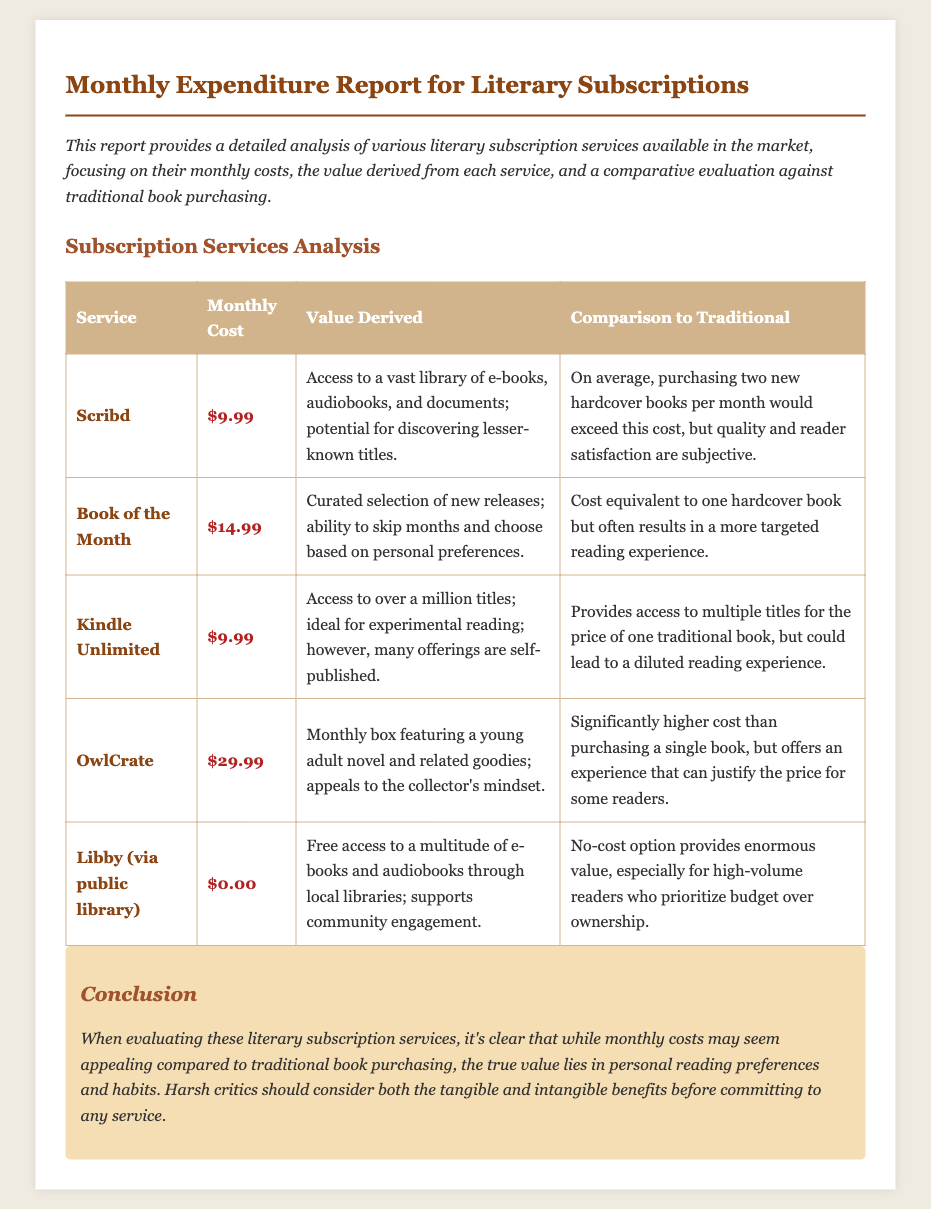What is the monthly cost of Scribd? The monthly cost of Scribd is stated in the document.
Answer: $9.99 What value does Kindle Unlimited provide? The document describes the value derived from Kindle Unlimited.
Answer: Access to over a million titles How much does OwlCrate cost per month? The cost of OwlCrate is clearly listed in the analysis section.
Answer: $29.99 What is unique about the value derived from Libby? The document mentions the distinctive benefits of using Libby.
Answer: Free access to a multitude of e-books and audiobooks Which subscription service offers a curated selection of new releases? The document explicitly identifies the service that provides a curated selection.
Answer: Book of the Month How does the cost of Kindle Unlimited compare to purchasing traditional books? The comparison discusses the cost relationship between Kindle Unlimited and traditional book purchasing.
Answer: Provides access to multiple titles for the price of one traditional book What is the conclusion drawn about evaluating literary subscription services? The conclusion section summarizes the insights about subscription services.
Answer: The true value lies in personal reading preferences and habits What is the highest monthly cost among the services listed? The question asks for the maximum cost of the listed services, which can be found in the table.
Answer: $29.99 What aspect does the document focus on in its analysis? The introduction specifies the focus area of the report.
Answer: Monthly costs, value derived from each service, and comparative evaluation against traditional book purchasing 